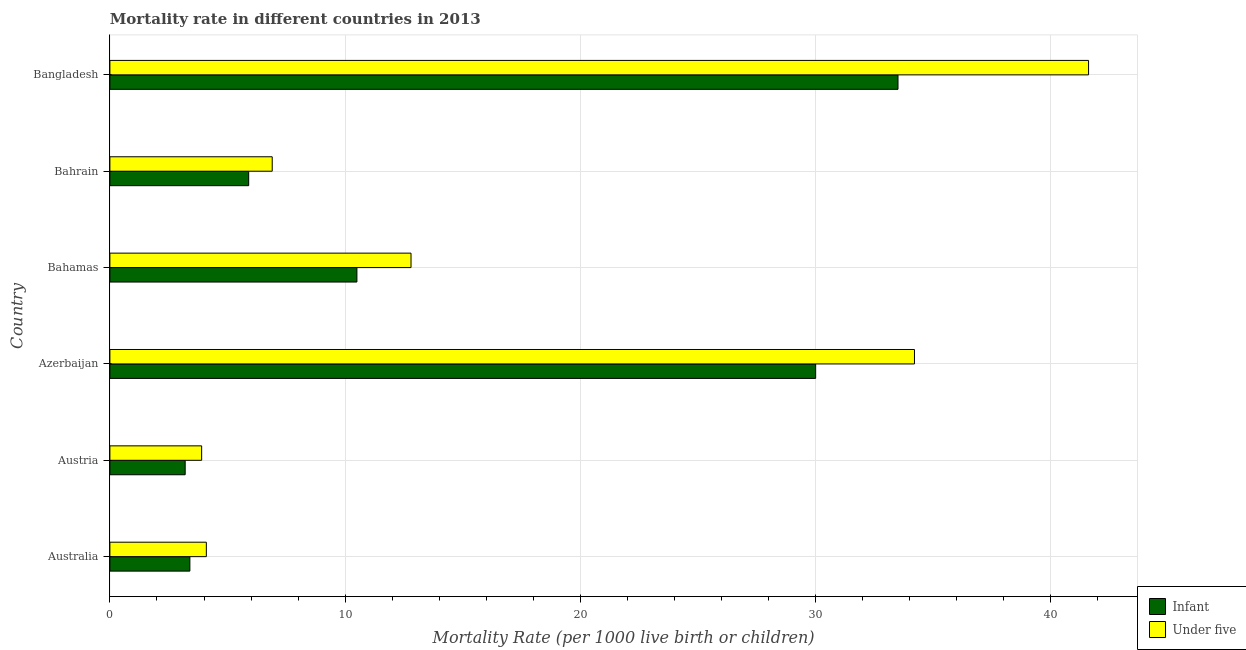Are the number of bars on each tick of the Y-axis equal?
Your answer should be very brief. Yes. How many bars are there on the 6th tick from the top?
Offer a terse response. 2. What is the label of the 2nd group of bars from the top?
Ensure brevity in your answer.  Bahrain. What is the under-5 mortality rate in Australia?
Offer a very short reply. 4.1. Across all countries, what is the maximum infant mortality rate?
Keep it short and to the point. 33.5. In which country was the under-5 mortality rate maximum?
Offer a very short reply. Bangladesh. In which country was the infant mortality rate minimum?
Offer a terse response. Austria. What is the total under-5 mortality rate in the graph?
Provide a succinct answer. 103.5. What is the difference between the infant mortality rate in Azerbaijan and that in Bangladesh?
Offer a terse response. -3.5. What is the difference between the under-5 mortality rate in Australia and the infant mortality rate in Bahrain?
Your answer should be very brief. -1.8. What is the average under-5 mortality rate per country?
Your response must be concise. 17.25. In how many countries, is the infant mortality rate greater than 18 ?
Your answer should be compact. 2. What is the ratio of the infant mortality rate in Bahamas to that in Bahrain?
Provide a succinct answer. 1.78. Is the difference between the infant mortality rate in Australia and Bangladesh greater than the difference between the under-5 mortality rate in Australia and Bangladesh?
Make the answer very short. Yes. What is the difference between the highest and the second highest infant mortality rate?
Make the answer very short. 3.5. What is the difference between the highest and the lowest under-5 mortality rate?
Your answer should be very brief. 37.7. What does the 1st bar from the top in Austria represents?
Your response must be concise. Under five. What does the 2nd bar from the bottom in Australia represents?
Make the answer very short. Under five. Does the graph contain any zero values?
Your answer should be compact. No. What is the title of the graph?
Your answer should be very brief. Mortality rate in different countries in 2013. What is the label or title of the X-axis?
Make the answer very short. Mortality Rate (per 1000 live birth or children). What is the Mortality Rate (per 1000 live birth or children) in Infant in Australia?
Provide a succinct answer. 3.4. What is the Mortality Rate (per 1000 live birth or children) of Under five in Australia?
Offer a terse response. 4.1. What is the Mortality Rate (per 1000 live birth or children) in Infant in Austria?
Give a very brief answer. 3.2. What is the Mortality Rate (per 1000 live birth or children) of Under five in Austria?
Offer a terse response. 3.9. What is the Mortality Rate (per 1000 live birth or children) of Infant in Azerbaijan?
Give a very brief answer. 30. What is the Mortality Rate (per 1000 live birth or children) of Under five in Azerbaijan?
Offer a terse response. 34.2. What is the Mortality Rate (per 1000 live birth or children) of Infant in Bahamas?
Make the answer very short. 10.5. What is the Mortality Rate (per 1000 live birth or children) in Infant in Bahrain?
Provide a succinct answer. 5.9. What is the Mortality Rate (per 1000 live birth or children) of Infant in Bangladesh?
Your answer should be compact. 33.5. What is the Mortality Rate (per 1000 live birth or children) of Under five in Bangladesh?
Offer a terse response. 41.6. Across all countries, what is the maximum Mortality Rate (per 1000 live birth or children) in Infant?
Give a very brief answer. 33.5. Across all countries, what is the maximum Mortality Rate (per 1000 live birth or children) in Under five?
Provide a succinct answer. 41.6. Across all countries, what is the minimum Mortality Rate (per 1000 live birth or children) in Infant?
Keep it short and to the point. 3.2. What is the total Mortality Rate (per 1000 live birth or children) of Infant in the graph?
Offer a very short reply. 86.5. What is the total Mortality Rate (per 1000 live birth or children) in Under five in the graph?
Make the answer very short. 103.5. What is the difference between the Mortality Rate (per 1000 live birth or children) of Infant in Australia and that in Austria?
Offer a terse response. 0.2. What is the difference between the Mortality Rate (per 1000 live birth or children) in Under five in Australia and that in Austria?
Make the answer very short. 0.2. What is the difference between the Mortality Rate (per 1000 live birth or children) in Infant in Australia and that in Azerbaijan?
Ensure brevity in your answer.  -26.6. What is the difference between the Mortality Rate (per 1000 live birth or children) in Under five in Australia and that in Azerbaijan?
Your response must be concise. -30.1. What is the difference between the Mortality Rate (per 1000 live birth or children) in Infant in Australia and that in Bangladesh?
Provide a succinct answer. -30.1. What is the difference between the Mortality Rate (per 1000 live birth or children) of Under five in Australia and that in Bangladesh?
Ensure brevity in your answer.  -37.5. What is the difference between the Mortality Rate (per 1000 live birth or children) of Infant in Austria and that in Azerbaijan?
Your answer should be compact. -26.8. What is the difference between the Mortality Rate (per 1000 live birth or children) of Under five in Austria and that in Azerbaijan?
Provide a short and direct response. -30.3. What is the difference between the Mortality Rate (per 1000 live birth or children) of Infant in Austria and that in Bahamas?
Keep it short and to the point. -7.3. What is the difference between the Mortality Rate (per 1000 live birth or children) in Under five in Austria and that in Bahrain?
Make the answer very short. -3. What is the difference between the Mortality Rate (per 1000 live birth or children) in Infant in Austria and that in Bangladesh?
Offer a very short reply. -30.3. What is the difference between the Mortality Rate (per 1000 live birth or children) in Under five in Austria and that in Bangladesh?
Keep it short and to the point. -37.7. What is the difference between the Mortality Rate (per 1000 live birth or children) of Under five in Azerbaijan and that in Bahamas?
Offer a terse response. 21.4. What is the difference between the Mortality Rate (per 1000 live birth or children) of Infant in Azerbaijan and that in Bahrain?
Offer a terse response. 24.1. What is the difference between the Mortality Rate (per 1000 live birth or children) of Under five in Azerbaijan and that in Bahrain?
Offer a very short reply. 27.3. What is the difference between the Mortality Rate (per 1000 live birth or children) in Under five in Azerbaijan and that in Bangladesh?
Give a very brief answer. -7.4. What is the difference between the Mortality Rate (per 1000 live birth or children) in Infant in Bahamas and that in Bahrain?
Provide a succinct answer. 4.6. What is the difference between the Mortality Rate (per 1000 live birth or children) in Under five in Bahamas and that in Bahrain?
Make the answer very short. 5.9. What is the difference between the Mortality Rate (per 1000 live birth or children) in Infant in Bahamas and that in Bangladesh?
Your answer should be compact. -23. What is the difference between the Mortality Rate (per 1000 live birth or children) in Under five in Bahamas and that in Bangladesh?
Provide a succinct answer. -28.8. What is the difference between the Mortality Rate (per 1000 live birth or children) of Infant in Bahrain and that in Bangladesh?
Your response must be concise. -27.6. What is the difference between the Mortality Rate (per 1000 live birth or children) in Under five in Bahrain and that in Bangladesh?
Make the answer very short. -34.7. What is the difference between the Mortality Rate (per 1000 live birth or children) in Infant in Australia and the Mortality Rate (per 1000 live birth or children) in Under five in Azerbaijan?
Provide a short and direct response. -30.8. What is the difference between the Mortality Rate (per 1000 live birth or children) in Infant in Australia and the Mortality Rate (per 1000 live birth or children) in Under five in Bahamas?
Your response must be concise. -9.4. What is the difference between the Mortality Rate (per 1000 live birth or children) in Infant in Australia and the Mortality Rate (per 1000 live birth or children) in Under five in Bahrain?
Ensure brevity in your answer.  -3.5. What is the difference between the Mortality Rate (per 1000 live birth or children) of Infant in Australia and the Mortality Rate (per 1000 live birth or children) of Under five in Bangladesh?
Keep it short and to the point. -38.2. What is the difference between the Mortality Rate (per 1000 live birth or children) in Infant in Austria and the Mortality Rate (per 1000 live birth or children) in Under five in Azerbaijan?
Provide a short and direct response. -31. What is the difference between the Mortality Rate (per 1000 live birth or children) in Infant in Austria and the Mortality Rate (per 1000 live birth or children) in Under five in Bahamas?
Ensure brevity in your answer.  -9.6. What is the difference between the Mortality Rate (per 1000 live birth or children) of Infant in Austria and the Mortality Rate (per 1000 live birth or children) of Under five in Bangladesh?
Provide a succinct answer. -38.4. What is the difference between the Mortality Rate (per 1000 live birth or children) in Infant in Azerbaijan and the Mortality Rate (per 1000 live birth or children) in Under five in Bahrain?
Offer a terse response. 23.1. What is the difference between the Mortality Rate (per 1000 live birth or children) in Infant in Azerbaijan and the Mortality Rate (per 1000 live birth or children) in Under five in Bangladesh?
Provide a short and direct response. -11.6. What is the difference between the Mortality Rate (per 1000 live birth or children) of Infant in Bahamas and the Mortality Rate (per 1000 live birth or children) of Under five in Bahrain?
Your response must be concise. 3.6. What is the difference between the Mortality Rate (per 1000 live birth or children) in Infant in Bahamas and the Mortality Rate (per 1000 live birth or children) in Under five in Bangladesh?
Give a very brief answer. -31.1. What is the difference between the Mortality Rate (per 1000 live birth or children) in Infant in Bahrain and the Mortality Rate (per 1000 live birth or children) in Under five in Bangladesh?
Provide a succinct answer. -35.7. What is the average Mortality Rate (per 1000 live birth or children) in Infant per country?
Make the answer very short. 14.42. What is the average Mortality Rate (per 1000 live birth or children) in Under five per country?
Give a very brief answer. 17.25. What is the difference between the Mortality Rate (per 1000 live birth or children) of Infant and Mortality Rate (per 1000 live birth or children) of Under five in Australia?
Offer a terse response. -0.7. What is the difference between the Mortality Rate (per 1000 live birth or children) of Infant and Mortality Rate (per 1000 live birth or children) of Under five in Azerbaijan?
Give a very brief answer. -4.2. What is the difference between the Mortality Rate (per 1000 live birth or children) of Infant and Mortality Rate (per 1000 live birth or children) of Under five in Bahamas?
Keep it short and to the point. -2.3. What is the difference between the Mortality Rate (per 1000 live birth or children) of Infant and Mortality Rate (per 1000 live birth or children) of Under five in Bahrain?
Keep it short and to the point. -1. What is the ratio of the Mortality Rate (per 1000 live birth or children) in Infant in Australia to that in Austria?
Your answer should be very brief. 1.06. What is the ratio of the Mortality Rate (per 1000 live birth or children) of Under five in Australia to that in Austria?
Offer a very short reply. 1.05. What is the ratio of the Mortality Rate (per 1000 live birth or children) in Infant in Australia to that in Azerbaijan?
Keep it short and to the point. 0.11. What is the ratio of the Mortality Rate (per 1000 live birth or children) of Under five in Australia to that in Azerbaijan?
Provide a succinct answer. 0.12. What is the ratio of the Mortality Rate (per 1000 live birth or children) in Infant in Australia to that in Bahamas?
Provide a short and direct response. 0.32. What is the ratio of the Mortality Rate (per 1000 live birth or children) of Under five in Australia to that in Bahamas?
Give a very brief answer. 0.32. What is the ratio of the Mortality Rate (per 1000 live birth or children) of Infant in Australia to that in Bahrain?
Provide a short and direct response. 0.58. What is the ratio of the Mortality Rate (per 1000 live birth or children) of Under five in Australia to that in Bahrain?
Make the answer very short. 0.59. What is the ratio of the Mortality Rate (per 1000 live birth or children) in Infant in Australia to that in Bangladesh?
Offer a terse response. 0.1. What is the ratio of the Mortality Rate (per 1000 live birth or children) in Under five in Australia to that in Bangladesh?
Keep it short and to the point. 0.1. What is the ratio of the Mortality Rate (per 1000 live birth or children) of Infant in Austria to that in Azerbaijan?
Ensure brevity in your answer.  0.11. What is the ratio of the Mortality Rate (per 1000 live birth or children) in Under five in Austria to that in Azerbaijan?
Provide a short and direct response. 0.11. What is the ratio of the Mortality Rate (per 1000 live birth or children) in Infant in Austria to that in Bahamas?
Offer a very short reply. 0.3. What is the ratio of the Mortality Rate (per 1000 live birth or children) in Under five in Austria to that in Bahamas?
Ensure brevity in your answer.  0.3. What is the ratio of the Mortality Rate (per 1000 live birth or children) of Infant in Austria to that in Bahrain?
Ensure brevity in your answer.  0.54. What is the ratio of the Mortality Rate (per 1000 live birth or children) of Under five in Austria to that in Bahrain?
Offer a terse response. 0.57. What is the ratio of the Mortality Rate (per 1000 live birth or children) in Infant in Austria to that in Bangladesh?
Your answer should be very brief. 0.1. What is the ratio of the Mortality Rate (per 1000 live birth or children) in Under five in Austria to that in Bangladesh?
Provide a succinct answer. 0.09. What is the ratio of the Mortality Rate (per 1000 live birth or children) of Infant in Azerbaijan to that in Bahamas?
Provide a succinct answer. 2.86. What is the ratio of the Mortality Rate (per 1000 live birth or children) in Under five in Azerbaijan to that in Bahamas?
Offer a very short reply. 2.67. What is the ratio of the Mortality Rate (per 1000 live birth or children) in Infant in Azerbaijan to that in Bahrain?
Provide a short and direct response. 5.08. What is the ratio of the Mortality Rate (per 1000 live birth or children) in Under five in Azerbaijan to that in Bahrain?
Make the answer very short. 4.96. What is the ratio of the Mortality Rate (per 1000 live birth or children) of Infant in Azerbaijan to that in Bangladesh?
Provide a succinct answer. 0.9. What is the ratio of the Mortality Rate (per 1000 live birth or children) of Under five in Azerbaijan to that in Bangladesh?
Provide a short and direct response. 0.82. What is the ratio of the Mortality Rate (per 1000 live birth or children) in Infant in Bahamas to that in Bahrain?
Offer a terse response. 1.78. What is the ratio of the Mortality Rate (per 1000 live birth or children) in Under five in Bahamas to that in Bahrain?
Make the answer very short. 1.86. What is the ratio of the Mortality Rate (per 1000 live birth or children) of Infant in Bahamas to that in Bangladesh?
Your answer should be very brief. 0.31. What is the ratio of the Mortality Rate (per 1000 live birth or children) of Under five in Bahamas to that in Bangladesh?
Your response must be concise. 0.31. What is the ratio of the Mortality Rate (per 1000 live birth or children) of Infant in Bahrain to that in Bangladesh?
Your answer should be very brief. 0.18. What is the ratio of the Mortality Rate (per 1000 live birth or children) in Under five in Bahrain to that in Bangladesh?
Your answer should be compact. 0.17. What is the difference between the highest and the second highest Mortality Rate (per 1000 live birth or children) in Infant?
Offer a terse response. 3.5. What is the difference between the highest and the lowest Mortality Rate (per 1000 live birth or children) of Infant?
Your answer should be very brief. 30.3. What is the difference between the highest and the lowest Mortality Rate (per 1000 live birth or children) in Under five?
Keep it short and to the point. 37.7. 